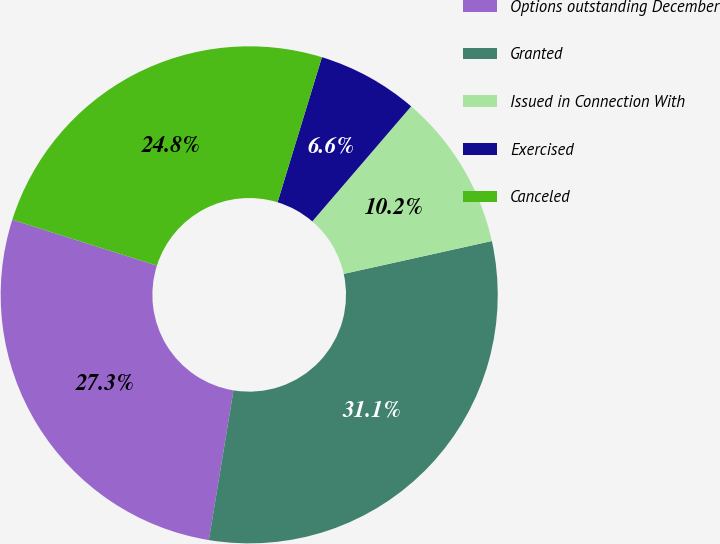<chart> <loc_0><loc_0><loc_500><loc_500><pie_chart><fcel>Options outstanding December<fcel>Granted<fcel>Issued in Connection With<fcel>Exercised<fcel>Canceled<nl><fcel>27.29%<fcel>31.07%<fcel>10.23%<fcel>6.57%<fcel>24.84%<nl></chart> 